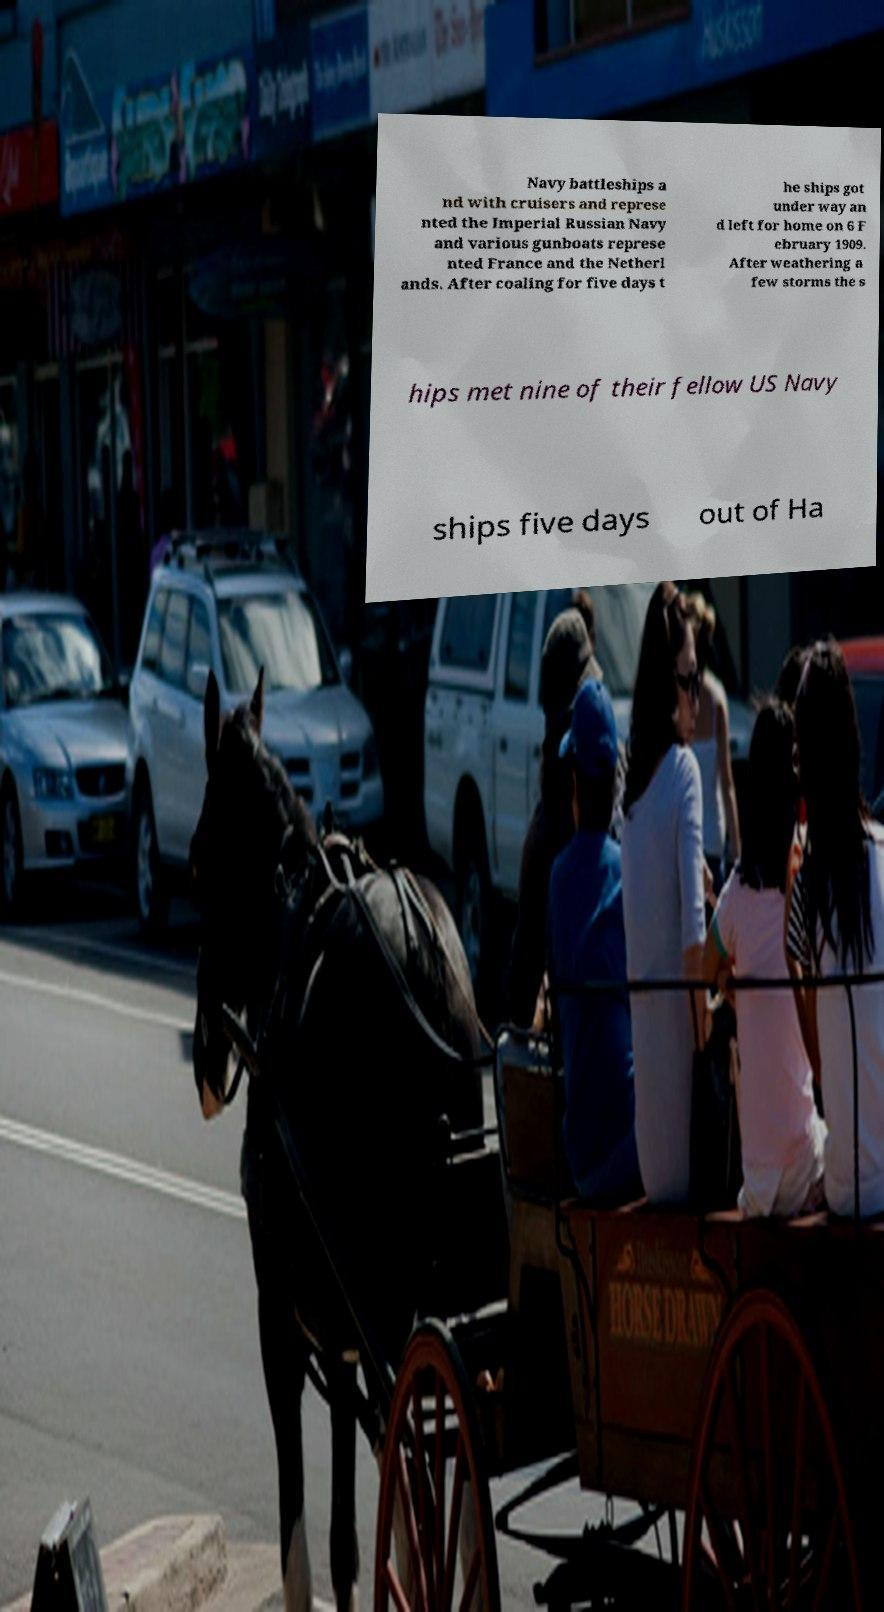Could you assist in decoding the text presented in this image and type it out clearly? Navy battleships a nd with cruisers and represe nted the Imperial Russian Navy and various gunboats represe nted France and the Netherl ands. After coaling for five days t he ships got under way an d left for home on 6 F ebruary 1909. After weathering a few storms the s hips met nine of their fellow US Navy ships five days out of Ha 